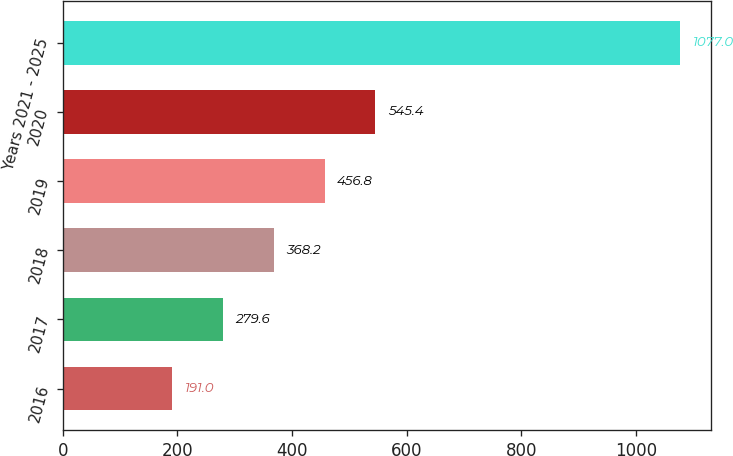<chart> <loc_0><loc_0><loc_500><loc_500><bar_chart><fcel>2016<fcel>2017<fcel>2018<fcel>2019<fcel>2020<fcel>Years 2021 - 2025<nl><fcel>191<fcel>279.6<fcel>368.2<fcel>456.8<fcel>545.4<fcel>1077<nl></chart> 